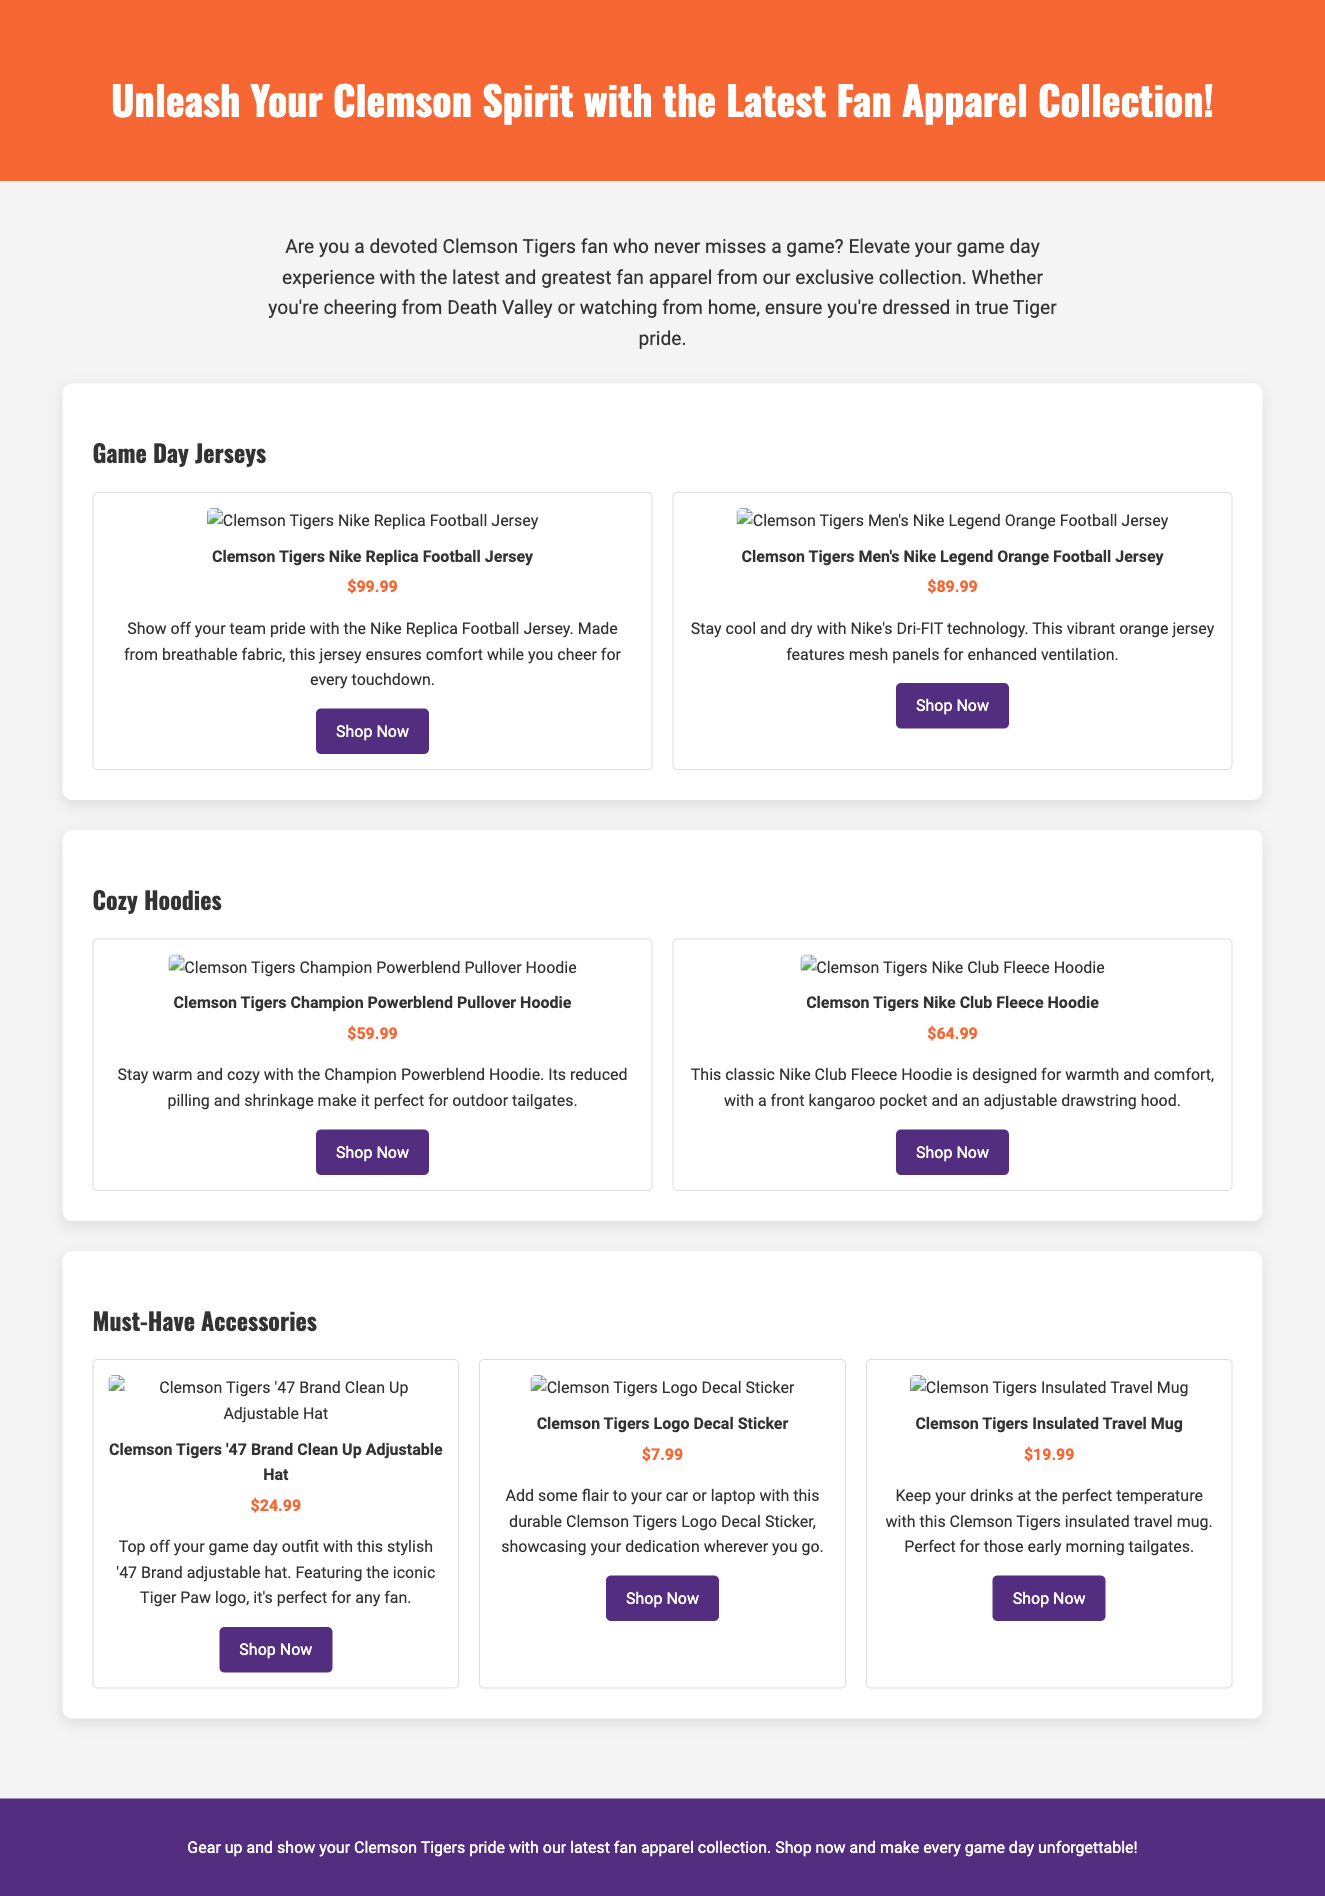what is the price of the Clemson Tigers Nike Replica Football Jersey? The price is listed directly in the document under the product details for the jersey.
Answer: $99.99 how many jerseys are featured in the product section? The document mentions two types of jerseys in the product section.
Answer: 2 what material technology is used in the Men's Nike Legend Orange Football Jersey? The document states that this jersey features Nike's Dri-FIT technology for cooling and drying.
Answer: Dri-FIT technology which hoodie has reduced pilling and shrinkage? The Champion Powerblend Pullover Hoodie is described with that feature in the document.
Answer: Champion Powerblend Pullover Hoodie what is the price of the Clemson Tigers Insulated Travel Mug? This price is provided in the accessories section of the document.
Answer: $19.99 how many accessories are listed in the product section? The document lists three different types of accessories available for purchase.
Answer: 3 which product features mesh panels for enhanced ventilation? The document refers to the Men's Nike Legend Orange Football Jersey having mesh panels for ventilation.
Answer: Men's Nike Legend Orange Football Jersey what is the color of the adjustable hat? The document indicates that the adjustable hat features the iconic Tiger Paw logo which is typically orange and purple.
Answer: Orange and purple 